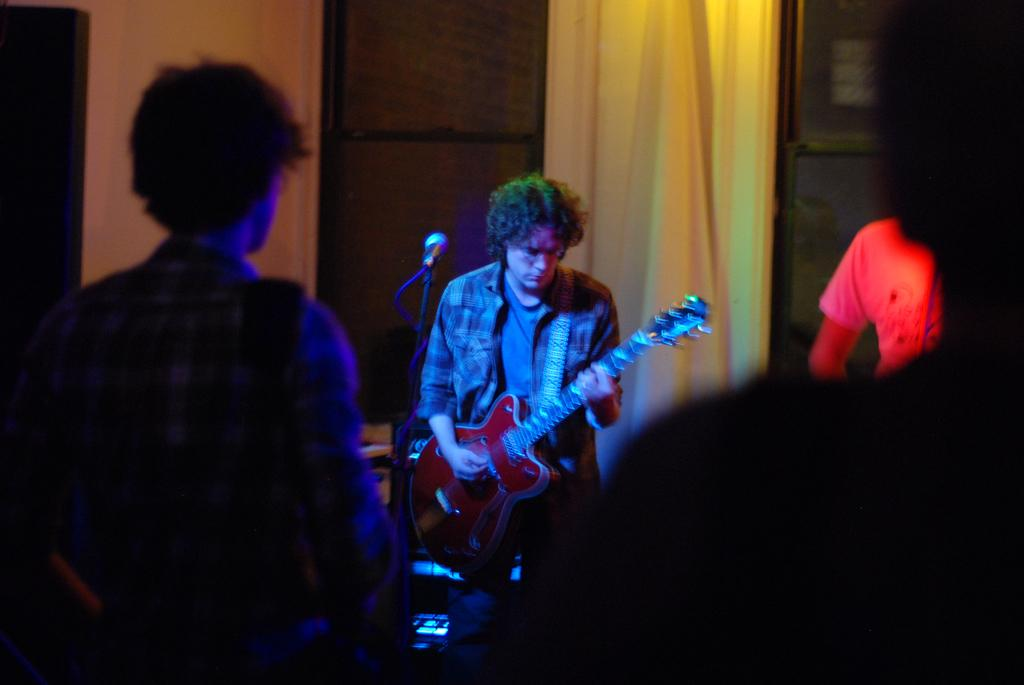What is the man in the image doing? The man is standing and playing a guitar. What is in front of the man? There is a microphone in front of the man. Who is observing the man in the image? There are people looking at the man. What can be seen in the background of the image? There is a wall and a curtain in the background of the image. How many tomatoes are on the wall behind the man? There are no tomatoes visible on the wall behind the man in the image. 